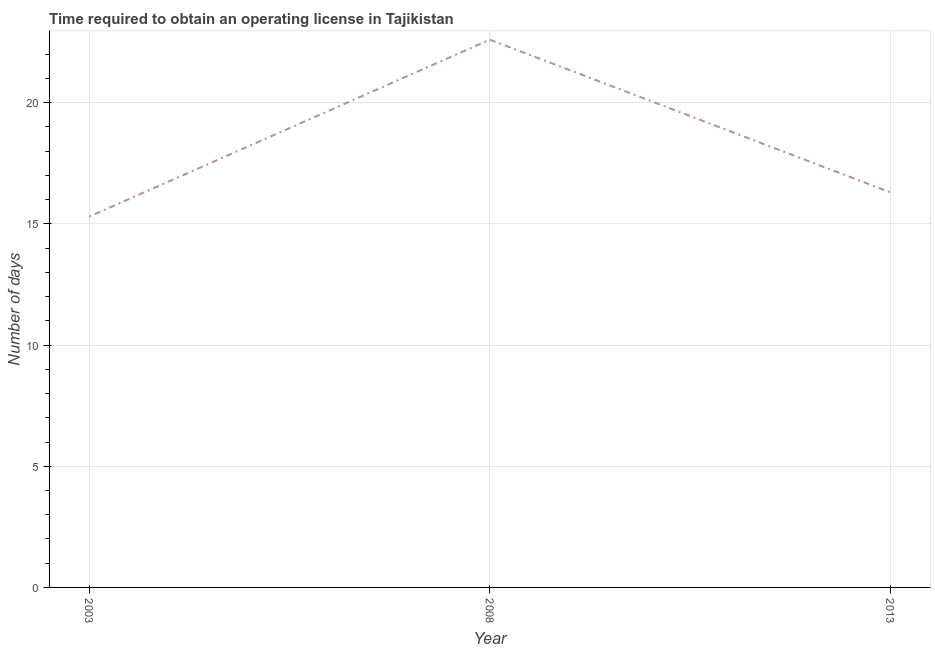Across all years, what is the maximum number of days to obtain operating license?
Give a very brief answer. 22.6. Across all years, what is the minimum number of days to obtain operating license?
Offer a terse response. 15.3. What is the sum of the number of days to obtain operating license?
Offer a terse response. 54.2. What is the difference between the number of days to obtain operating license in 2008 and 2013?
Your answer should be compact. 6.3. What is the average number of days to obtain operating license per year?
Your answer should be compact. 18.07. What is the median number of days to obtain operating license?
Make the answer very short. 16.3. In how many years, is the number of days to obtain operating license greater than 4 days?
Offer a very short reply. 3. Do a majority of the years between 2003 and 2008 (inclusive) have number of days to obtain operating license greater than 11 days?
Make the answer very short. Yes. What is the ratio of the number of days to obtain operating license in 2008 to that in 2013?
Offer a terse response. 1.39. Is the number of days to obtain operating license in 2003 less than that in 2013?
Your answer should be compact. Yes. Is the difference between the number of days to obtain operating license in 2003 and 2008 greater than the difference between any two years?
Make the answer very short. Yes. What is the difference between the highest and the second highest number of days to obtain operating license?
Your answer should be compact. 6.3. What is the difference between the highest and the lowest number of days to obtain operating license?
Your response must be concise. 7.3. Does the number of days to obtain operating license monotonically increase over the years?
Make the answer very short. No. How many years are there in the graph?
Offer a very short reply. 3. Are the values on the major ticks of Y-axis written in scientific E-notation?
Offer a terse response. No. What is the title of the graph?
Your response must be concise. Time required to obtain an operating license in Tajikistan. What is the label or title of the Y-axis?
Your answer should be very brief. Number of days. What is the Number of days in 2003?
Make the answer very short. 15.3. What is the Number of days in 2008?
Offer a terse response. 22.6. What is the ratio of the Number of days in 2003 to that in 2008?
Ensure brevity in your answer.  0.68. What is the ratio of the Number of days in 2003 to that in 2013?
Provide a succinct answer. 0.94. What is the ratio of the Number of days in 2008 to that in 2013?
Your response must be concise. 1.39. 